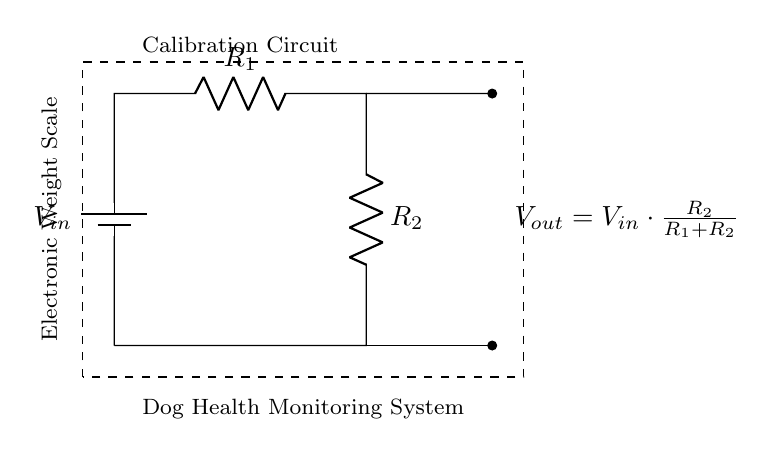What are the components in this circuit? The circuit has a battery, two resistors (R1 and R2), and a load (the electronic weight scale). The battery provides the input voltage, the resistors are used to create the voltage divider, and the output is connected to the weight scale.
Answer: Battery, R1, R2, Electronic Weight Scale What is the function of R1 and R2? R1 and R2 form a voltage divider to reduce the input voltage for the electronic weight scale. The voltage at the output is a fraction of the input voltage determined by the resistances of R1 and R2.
Answer: Voltage divider What is the formula for Vout? The formula for the output voltage (Vout) is given as Vout = Vin * (R2 / (R1 + R2)). This indicates how the output is calculated based on the resistances and input voltage.
Answer: Vout = Vin * (R2 / (R1 + R2)) How does increasing R2 affect Vout? Increasing R2 increases the output voltage (Vout) because a larger R2 means that a greater fraction of the input voltage is applied across it, according to the voltage divider formula.
Answer: Increases Vout What is the purpose of the voltage divider in this circuit? The voltage divider calibrates the electronic weight scale by providing a specific output voltage that corresponds to the desired range of the weight measurements. This allows for accurate readings based on the input voltage.
Answer: Calibration What happens to Vout if R1 is much larger than R2? If R1 is much larger than R2, Vout will be very small because most of the input voltage appears across R1, leaving little for R2. Hence, the output voltage will be closer to zero.
Answer: Vout approaches zero 